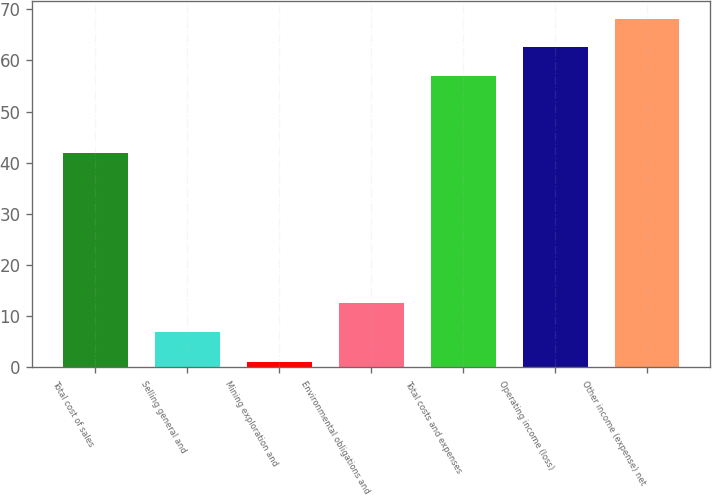Convert chart to OTSL. <chart><loc_0><loc_0><loc_500><loc_500><bar_chart><fcel>Total cost of sales<fcel>Selling general and<fcel>Mining exploration and<fcel>Environmental obligations and<fcel>Total costs and expenses<fcel>Operating income (loss)<fcel>Other income (expense) net<nl><fcel>42<fcel>7<fcel>1<fcel>12.6<fcel>57<fcel>62.6<fcel>68.2<nl></chart> 